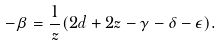Convert formula to latex. <formula><loc_0><loc_0><loc_500><loc_500>- \beta = \frac { 1 } { z } ( 2 d + 2 z - \gamma - \delta - \epsilon ) .</formula> 